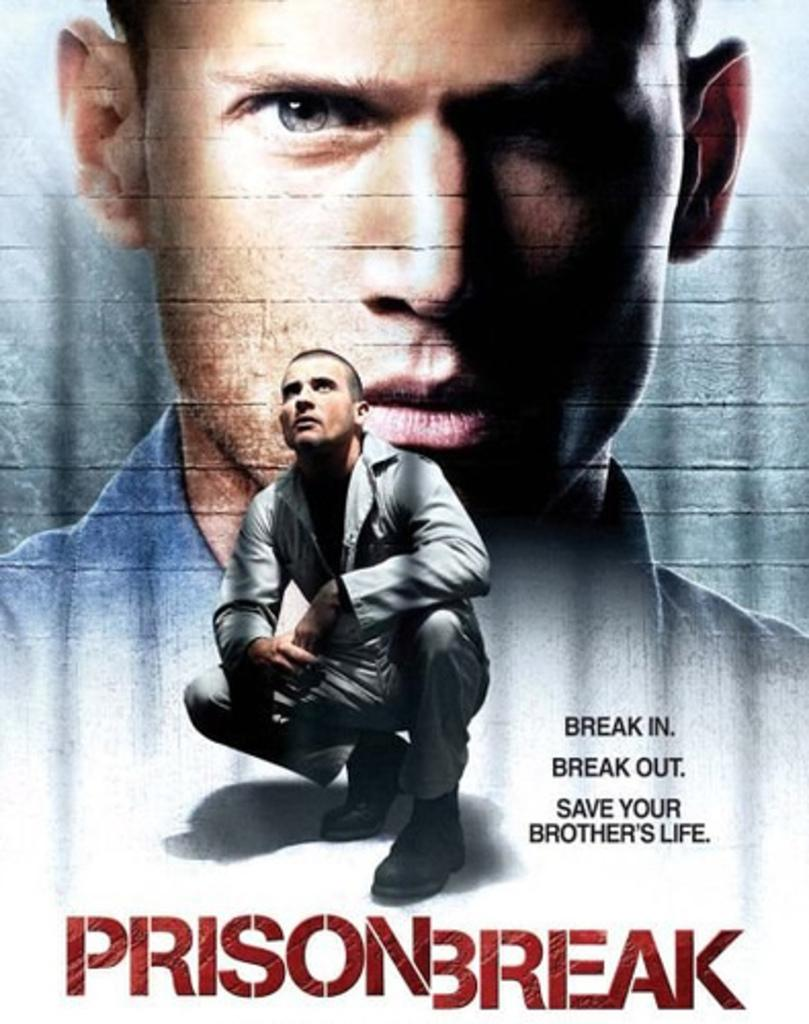Provide a one-sentence caption for the provided image. A movie poster titled prison break with an image of a man on it. 